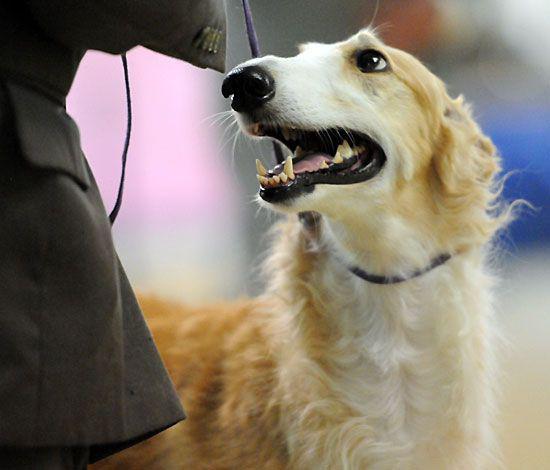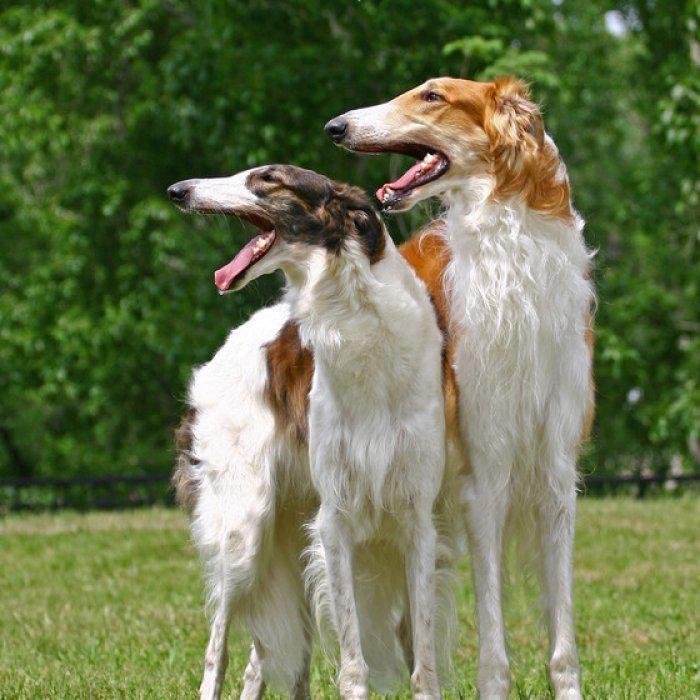The first image is the image on the left, the second image is the image on the right. For the images shown, is this caption "The right image contains two dogs." true? Answer yes or no. Yes. The first image is the image on the left, the second image is the image on the right. Given the left and right images, does the statement "At least one of the dogs has its mouth open" hold true? Answer yes or no. Yes. 